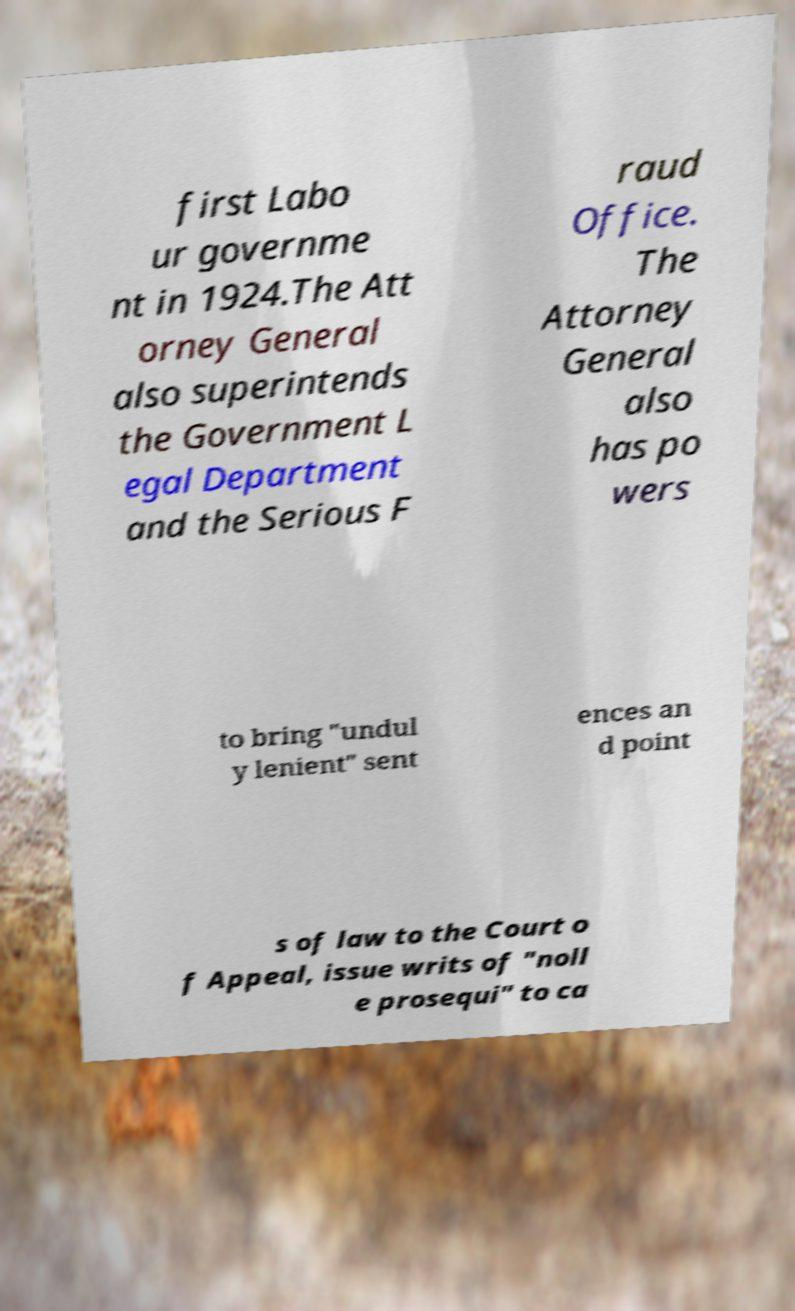Please identify and transcribe the text found in this image. first Labo ur governme nt in 1924.The Att orney General also superintends the Government L egal Department and the Serious F raud Office. The Attorney General also has po wers to bring "undul y lenient" sent ences an d point s of law to the Court o f Appeal, issue writs of "noll e prosequi" to ca 